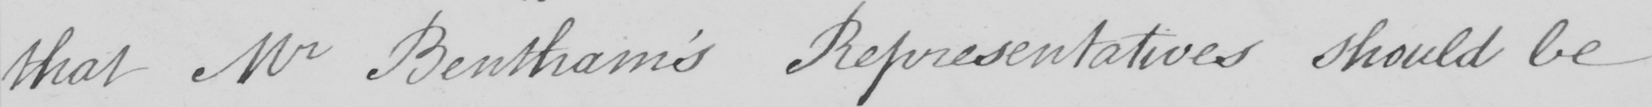Can you tell me what this handwritten text says? that Mr Bentham ' s Representatives should be 